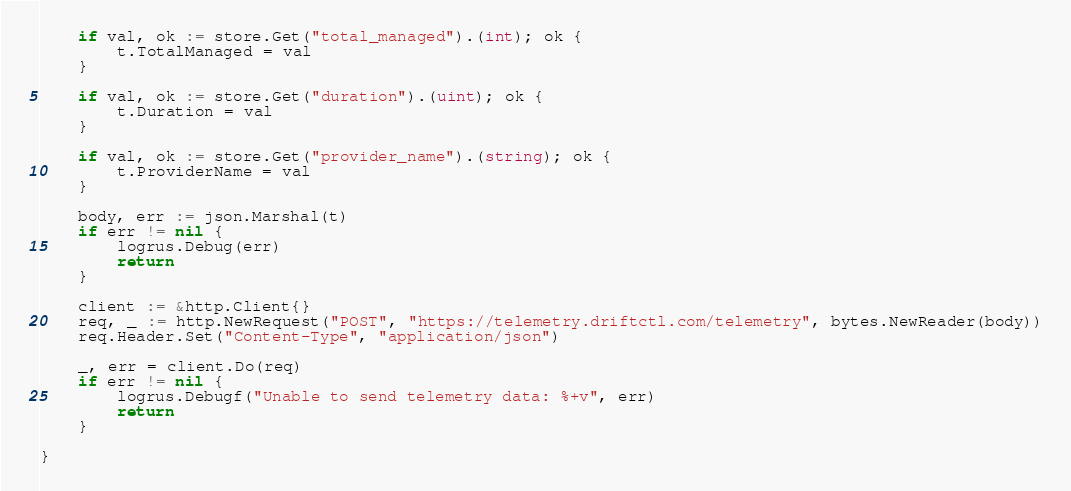<code> <loc_0><loc_0><loc_500><loc_500><_Go_>
	if val, ok := store.Get("total_managed").(int); ok {
		t.TotalManaged = val
	}

	if val, ok := store.Get("duration").(uint); ok {
		t.Duration = val
	}

	if val, ok := store.Get("provider_name").(string); ok {
		t.ProviderName = val
	}

	body, err := json.Marshal(t)
	if err != nil {
		logrus.Debug(err)
		return
	}

	client := &http.Client{}
	req, _ := http.NewRequest("POST", "https://telemetry.driftctl.com/telemetry", bytes.NewReader(body))
	req.Header.Set("Content-Type", "application/json")

	_, err = client.Do(req)
	if err != nil {
		logrus.Debugf("Unable to send telemetry data: %+v", err)
		return
	}

}
</code> 